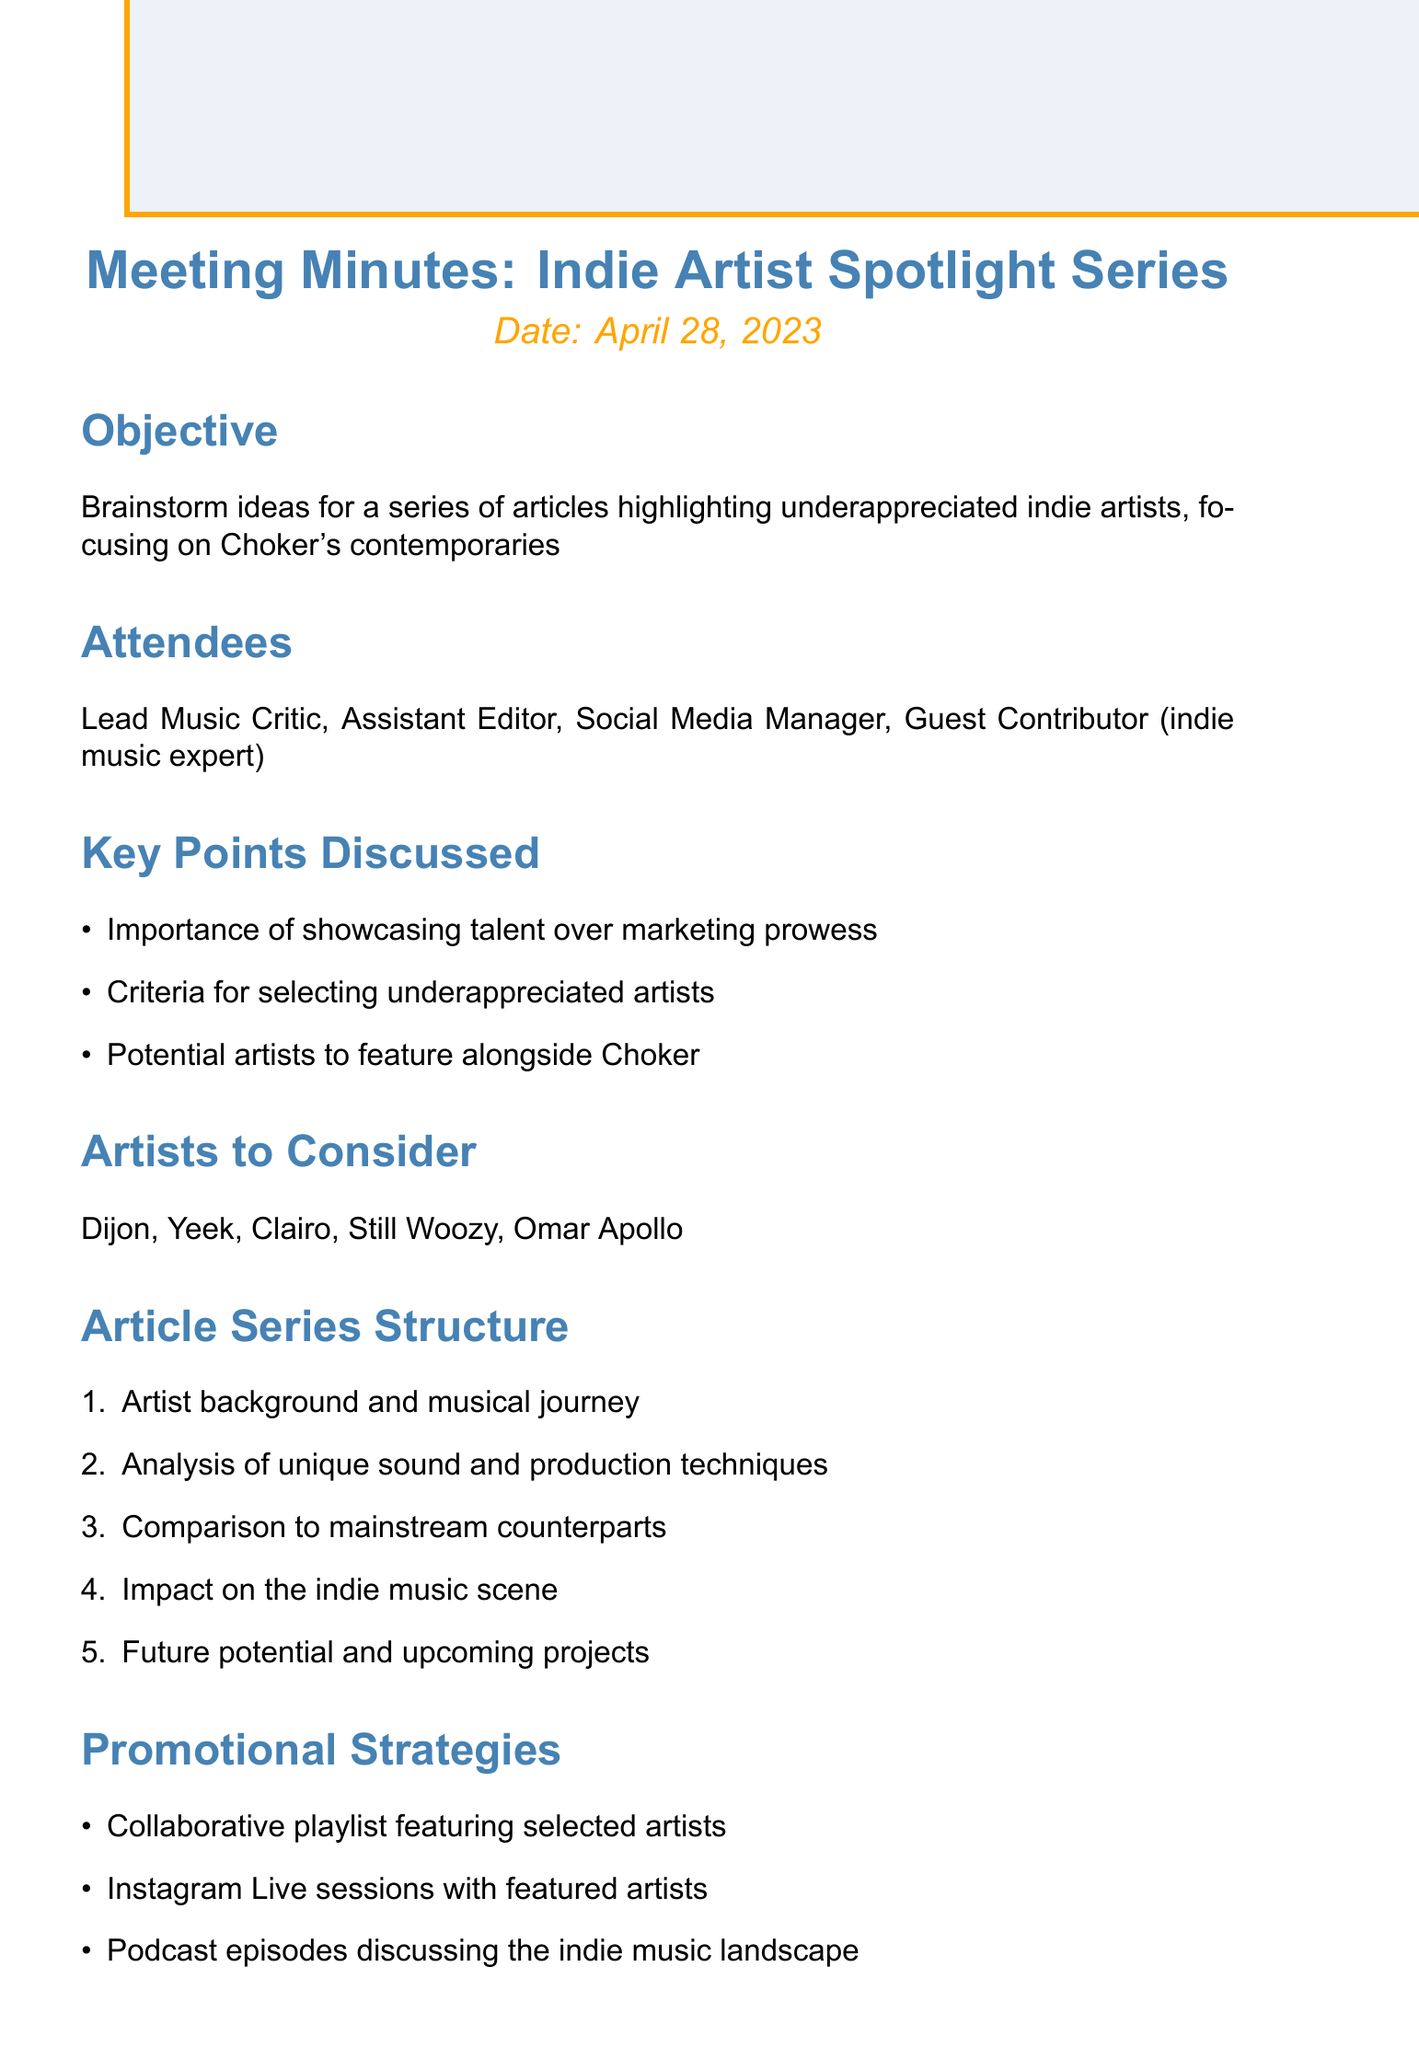what is the meeting objective? The meeting objective is stated in the document as brainstorming ideas for highlighting underappreciated indie artists, especially focusing on Choker's contemporaries.
Answer: Brainstorm ideas for a series of articles highlighting underappreciated indie artists, focusing on Choker's contemporaries who attended the meeting? The attendees of the meeting are listed, which includes various roles related to the project.
Answer: Lead Music Critic, Assistant Editor, Social Media Manager, Guest Contributor (indie music expert) what date is the next meeting scheduled for? The document specifies the date for the next meeting so attendees can plan accordingly.
Answer: May 15, 2023 name one artist to consider for the series. The document provides a list of potential artists that can be featured alongside Choker.
Answer: Dijon how many points were discussed in the key points section? The number of items listed under key points indicates the breadth of discussion topics.
Answer: 3 what is the first item in the article series structure? The structure outlines how the articles will be formatted, starting with the first element.
Answer: Artist background and musical journey list one promotional strategy mentioned. The promotional strategies are critical for raising awareness about the article series.
Answer: Collaborative playlist featuring selected artists what is one action item that needs to be completed? Documenting the action items helps track what tasks need to be accomplished for the project.
Answer: Research and compile list of 10 underappreciated artists 